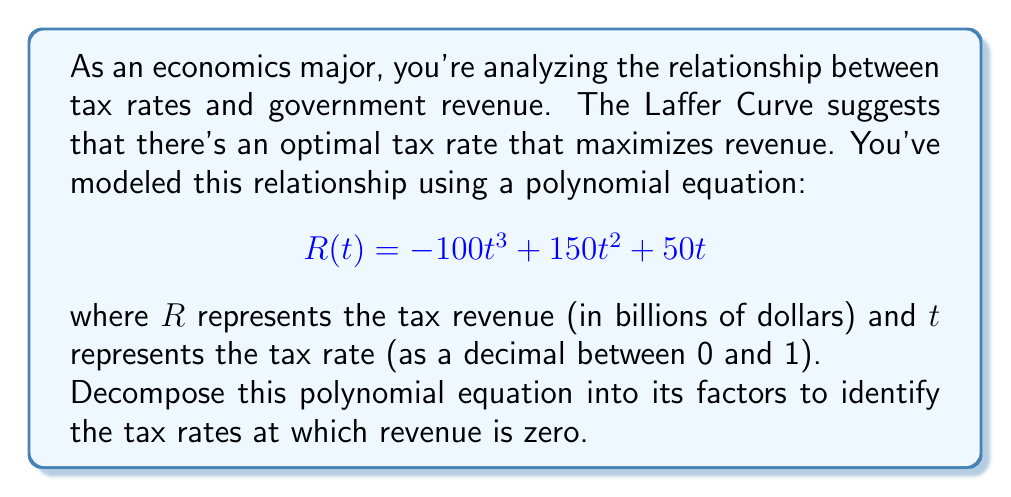Solve this math problem. To decompose this polynomial equation, we'll follow these steps:

1) First, let's factor out the greatest common factor (GCF):
   $$R(t) = -100t^3 + 150t^2 + 50t$$
   $$R(t) = 50t(-2t^2 + 3t + 1)$$

2) Now we need to factor the quadratic expression inside the parentheses. Let's check if it's factorable by using the quadratic formula or by inspection.

3) The quadratic expression is $-2t^2 + 3t + 1$. We can factor this by grouping:
   $$-2t^2 + 3t + 1 = (-2t^2 + t) + (2t + 1)$$
   $$= t(-2t + 1) + 1(-2t + 1)$$
   $$= (t + 1)(-2t + 1)$$

4) Putting it all together, we get:
   $$R(t) = 50t(t + 1)(-2t + 1)$$

5) To find where revenue is zero, we set each factor to zero and solve:
   
   50t = 0, so t = 0
   t + 1 = 0, so t = -1 (but this is outside our domain of 0 to 1)
   -2t + 1 = 0, so t = 1/2

Therefore, revenue is zero when the tax rate is 0 or 1/2 (50%).

This decomposition illustrates key points on the Laffer Curve: no revenue at 0% tax rate, maximum revenue at some intermediate rate, and declining revenue as the rate approaches 100% (in this case, reaching zero again at 50%).
Answer: $$R(t) = 50t(t + 1)(-2t + 1)$$
Revenue is zero when t = 0 or t = 1/2. 